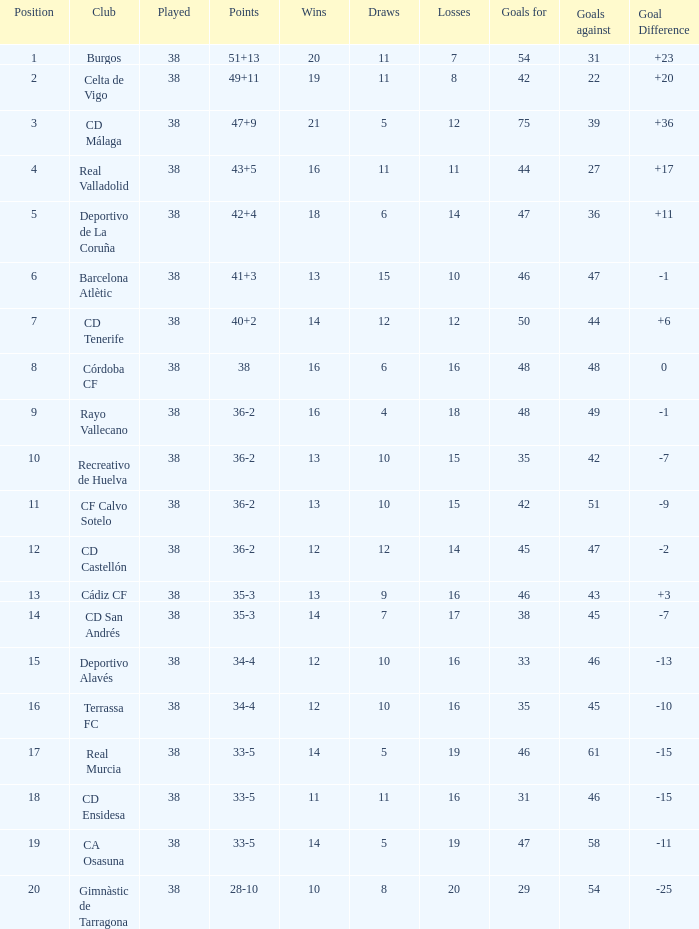What is the mean loss with a target greater than 51 and victories over 14? None. 